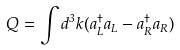<formula> <loc_0><loc_0><loc_500><loc_500>Q = \int d ^ { 3 } k ( a ^ { \dag } _ { L } a _ { L } - a ^ { \dag } _ { R } a _ { R } )</formula> 